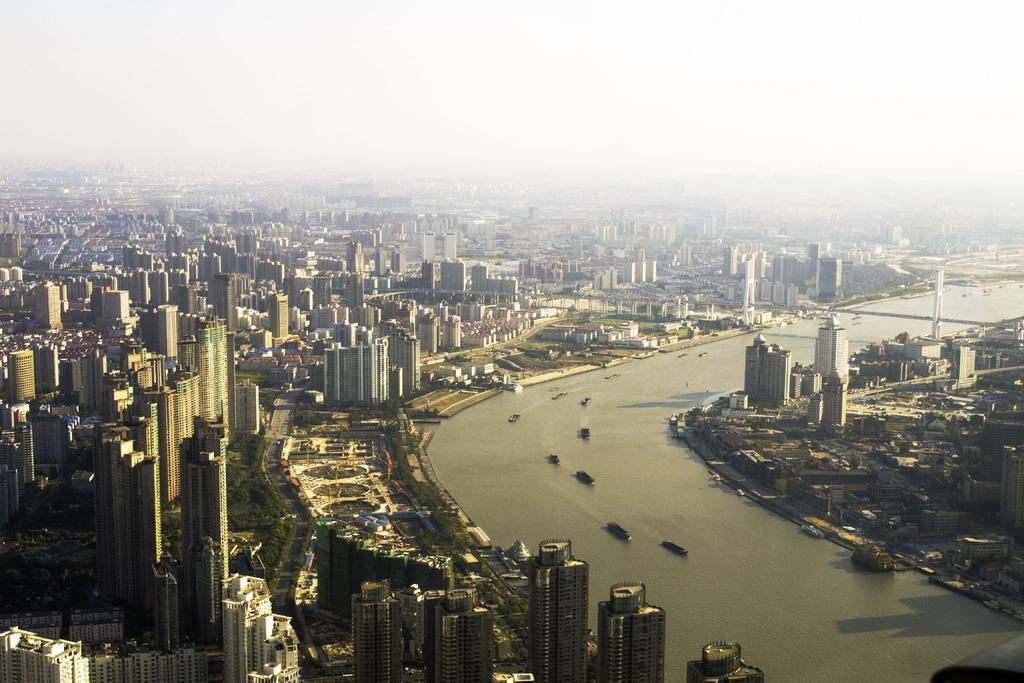What is in the water in the image? There are boats in the water in the image. What else can be seen in the image besides the boats? There are buildings visible in the image. What is visible at the top of the image? The sky is visible at the top of the image. How many eggs can be seen in the image? There are no eggs present in the image. Is there a tiger visible in the image? There is no tiger present in the image. 